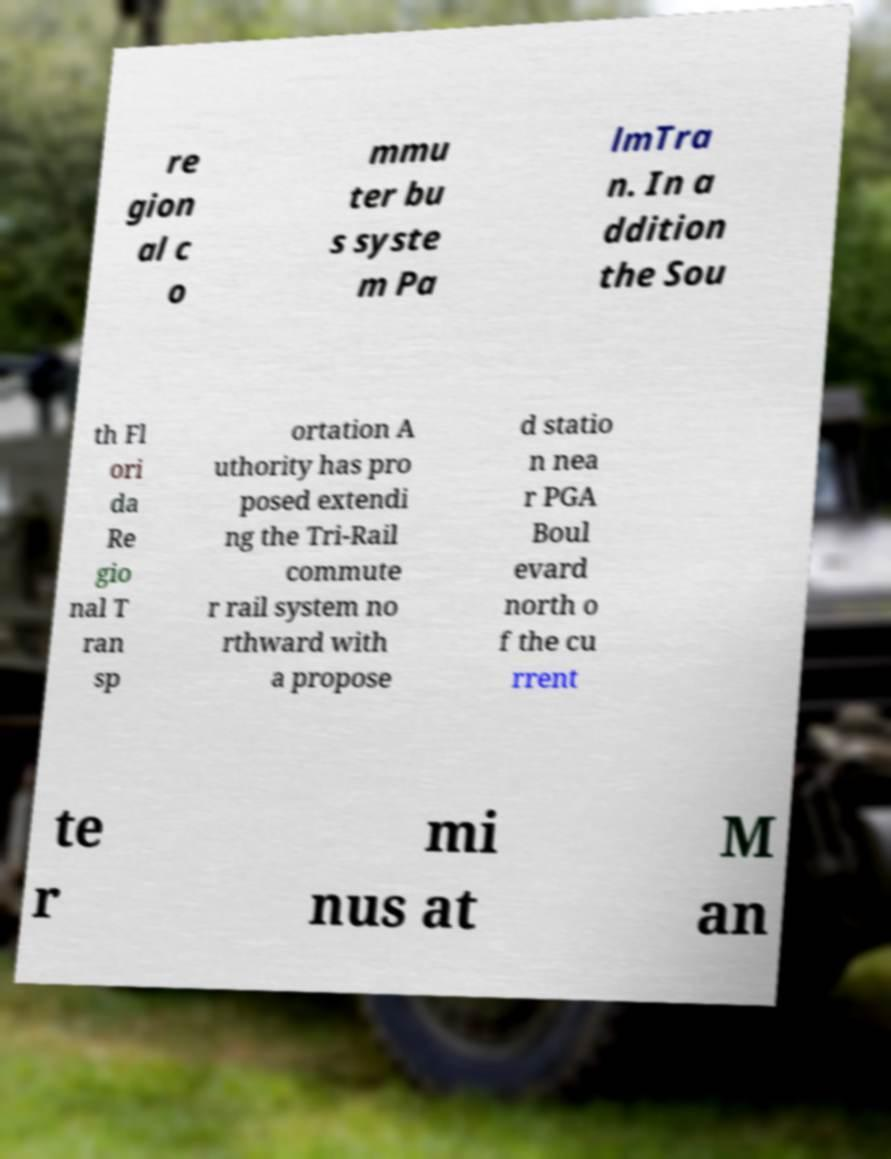Can you read and provide the text displayed in the image?This photo seems to have some interesting text. Can you extract and type it out for me? re gion al c o mmu ter bu s syste m Pa lmTra n. In a ddition the Sou th Fl ori da Re gio nal T ran sp ortation A uthority has pro posed extendi ng the Tri-Rail commute r rail system no rthward with a propose d statio n nea r PGA Boul evard north o f the cu rrent te r mi nus at M an 